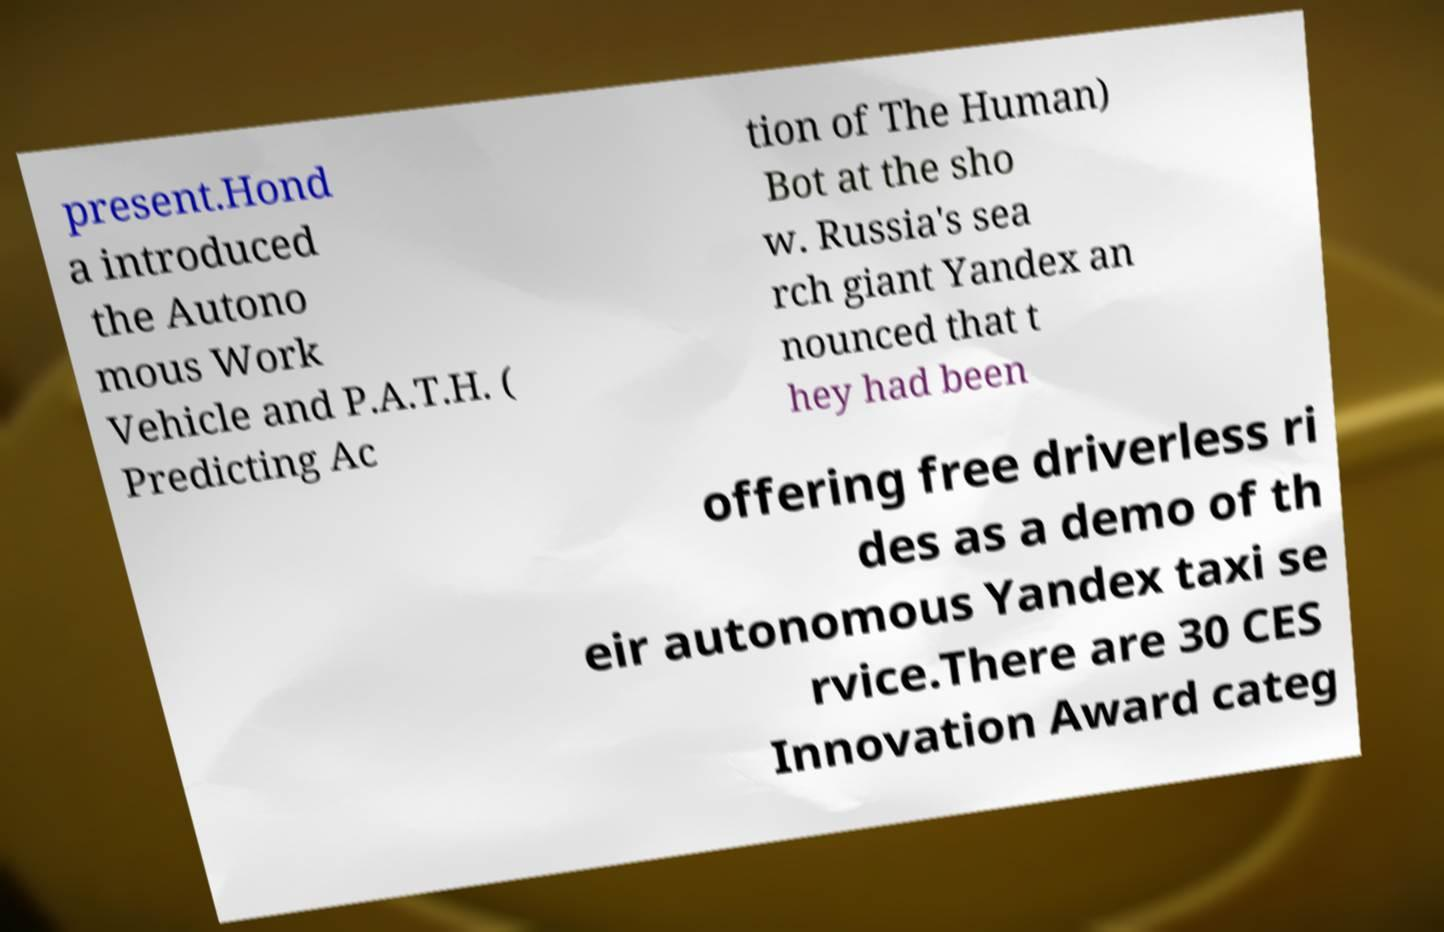I need the written content from this picture converted into text. Can you do that? present.Hond a introduced the Autono mous Work Vehicle and P.A.T.H. ( Predicting Ac tion of The Human) Bot at the sho w. Russia's sea rch giant Yandex an nounced that t hey had been offering free driverless ri des as a demo of th eir autonomous Yandex taxi se rvice.There are 30 CES Innovation Award categ 